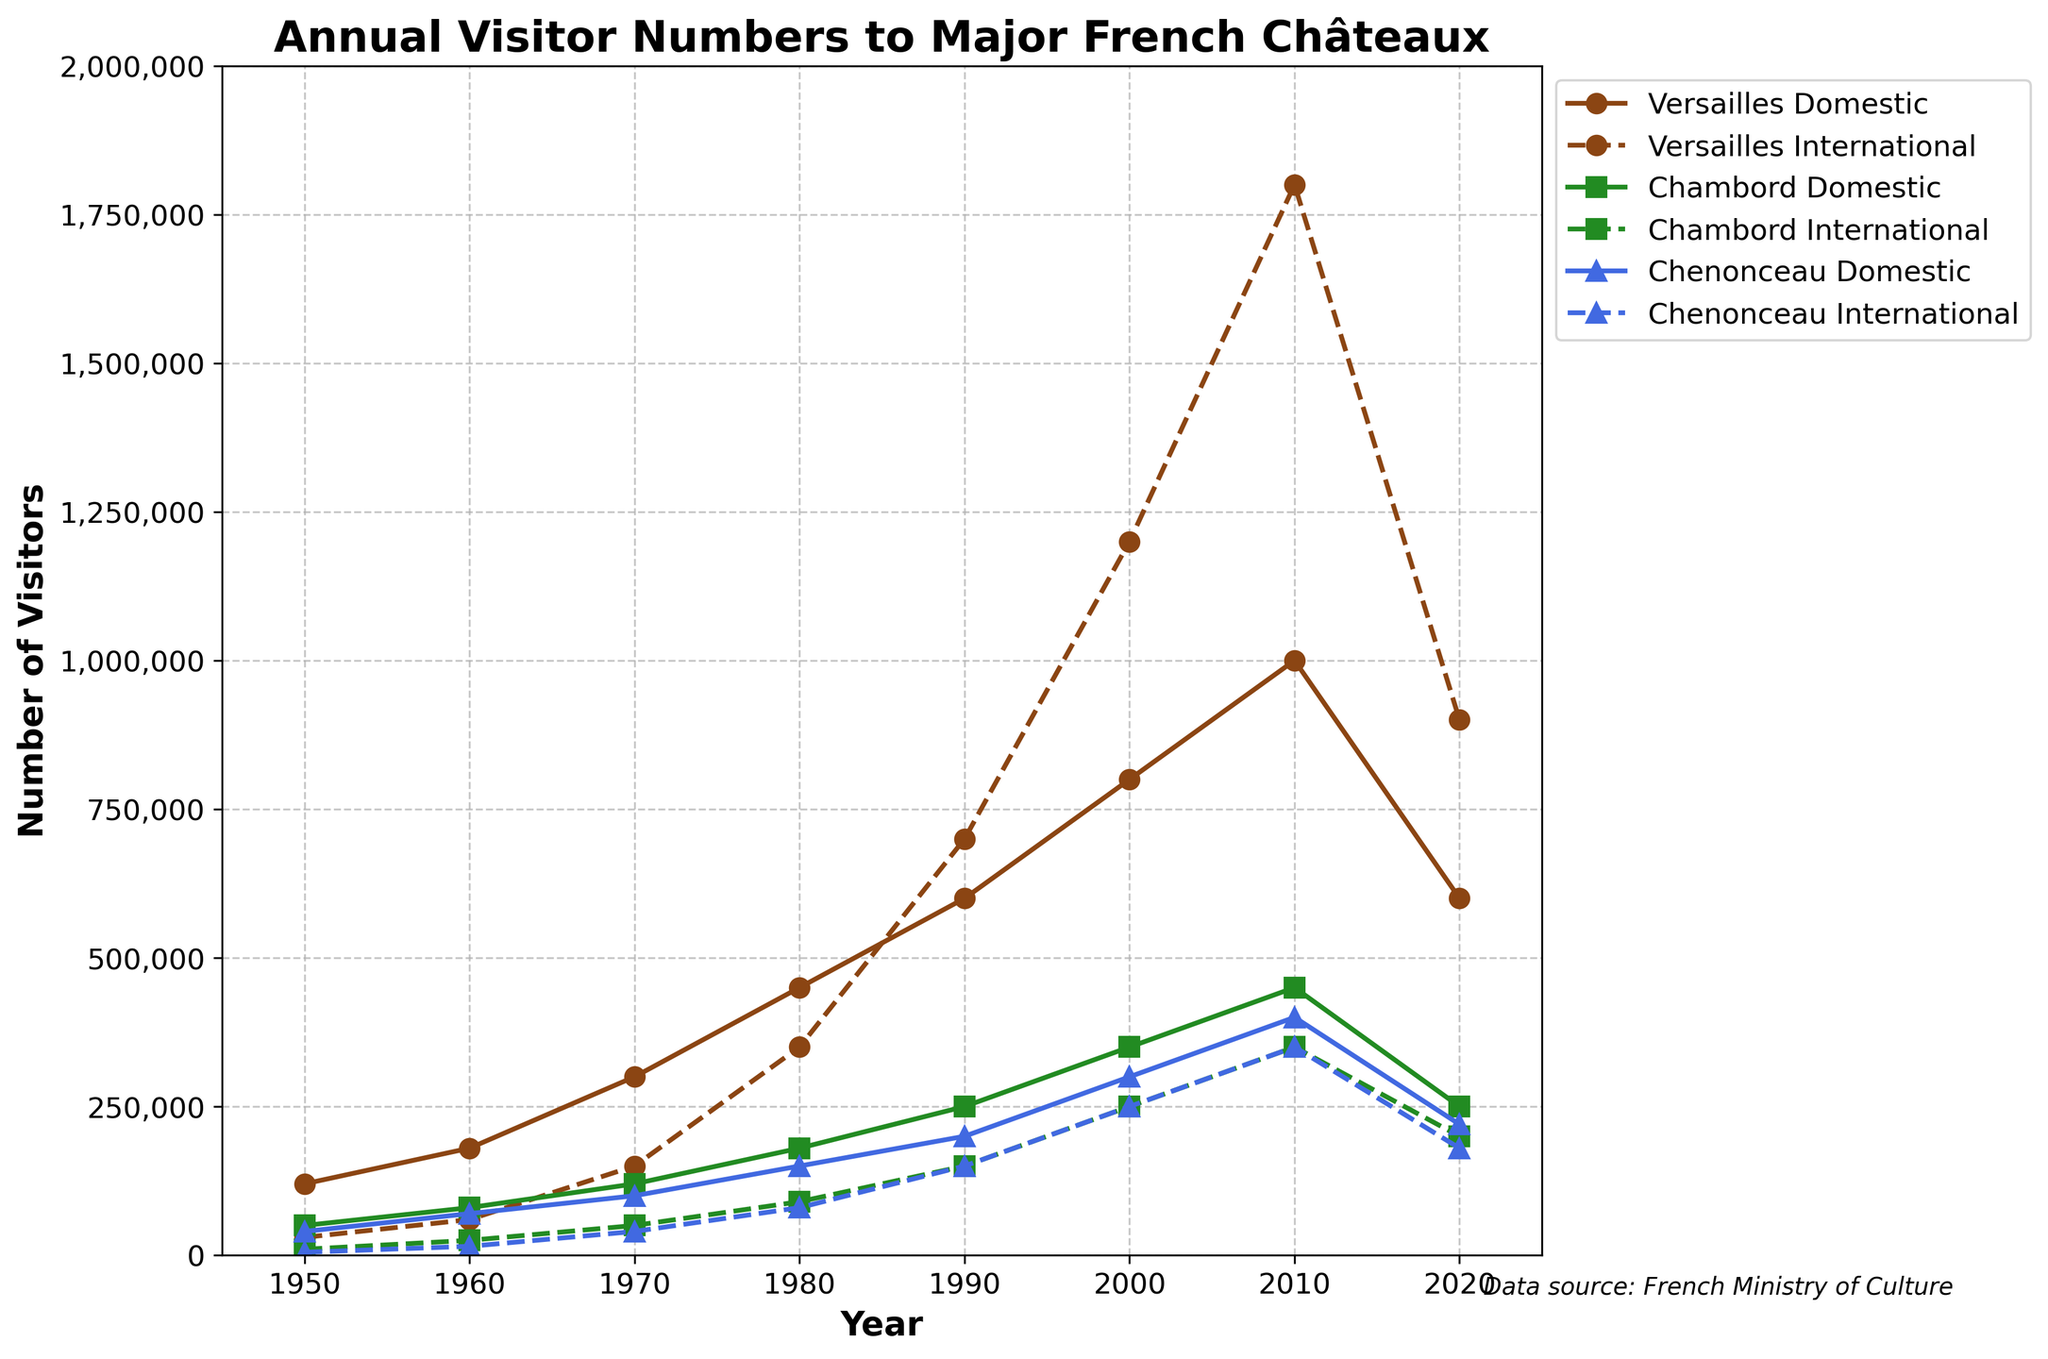What's the maximum number of visitors Château de Versailles has received in a single year? Look for the highest point on both the domestic and international lines for Château de Versailles. The international line reaches the highest value of 1,800,000 visitors in 2010.
Answer: 1,800,000 Which year saw the highest combined number of domestic and international visitors at Château de Chenonceau? Sum the domestic and international visitors for each year and identify the maximum. The highest combined number (750,000 visitors) occurred in 2010 (400,000 domestic + 350,000 international).
Answer: 2010 How did the number of domestic visitors to Château de Chambord in 2020 compare to 1950? Compare the values for the years 2020 and 1950. Château de Chambord had 250,000 domestic visitors in 2020 and 50,000 in 1950, showing a significant increase.
Answer: Increased by 200,000 What is the trend in international visitor numbers to Château de Versailles from 1950 to 2020? Identify the trajectory of the international visitor line for Château de Versailles. It shows a general upward trend from 30,000 visitors in 1950 to a peak of 1,800,000 in 2010, followed by a decrease to 900,000 in 2020.
Answer: Upward trend followed by a decrease For Château de Chambord, which year saw the greatest increase in domestic tourism compared to the previous decade? Calculate the change in domestic visitor numbers for each decade. The greatest increase occurs between 1960 (80,000) and 1970 (120,000), an increase of 40,000 visitors.
Answer: 1970 What is the difference between the combined domestic and international visitors at Château de Versailles and Château de Chambord in 2000? Calculate the combined visitors for both châteaux in 2000: Versailles (2,000,000) and Chambord (600,000). The difference is 2,000,000 - 600,000 = 1,400,000.
Answer: 1,400,000 Which château had the smallest number of international visitors in 1980? By comparing international visitor numbers for 1980, Château de Chenonceau had the smallest number (80,000) compared to Château de Versailles and Château de Chambord.
Answer: Château de Chenonceau 